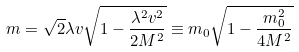Convert formula to latex. <formula><loc_0><loc_0><loc_500><loc_500>m = \sqrt { 2 } \lambda v \sqrt { 1 - \frac { \lambda ^ { 2 } v ^ { 2 } } { 2 M ^ { 2 } } } \equiv m _ { 0 } \sqrt { 1 - \frac { m _ { 0 } ^ { 2 } } { 4 M ^ { 2 } } }</formula> 